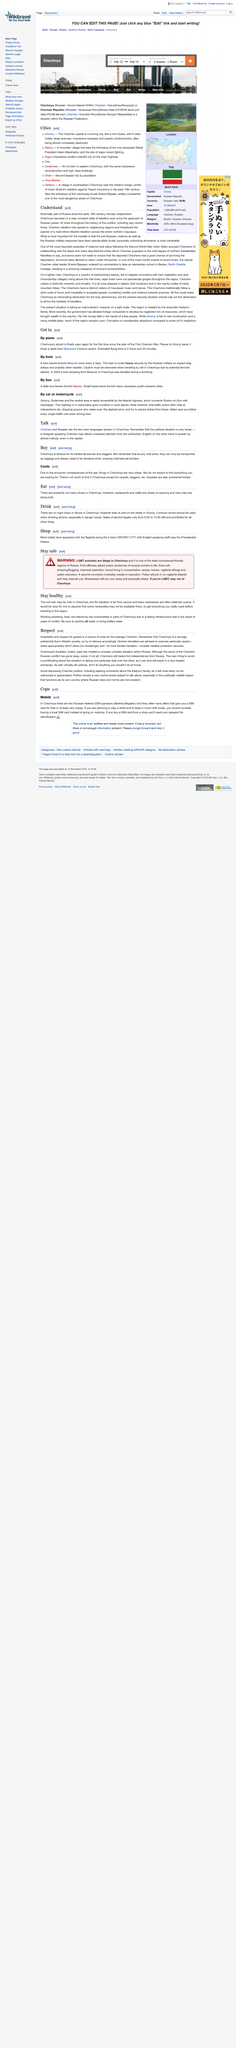Specify some key components in this picture. It is possible to travel to Grozny by car or motorcycle. The average Chechen takes pride in their hospitality and respect for guests, which is a defining characteristic of their culture. Yes, it is possible to travel to Chechnya by plane, train, and bus. It is recommended that lone female travelers consider reliable protection services to ensure their safety and security while traveling. There is a train that departs from Moscow to Chechnya once every 2 days. 